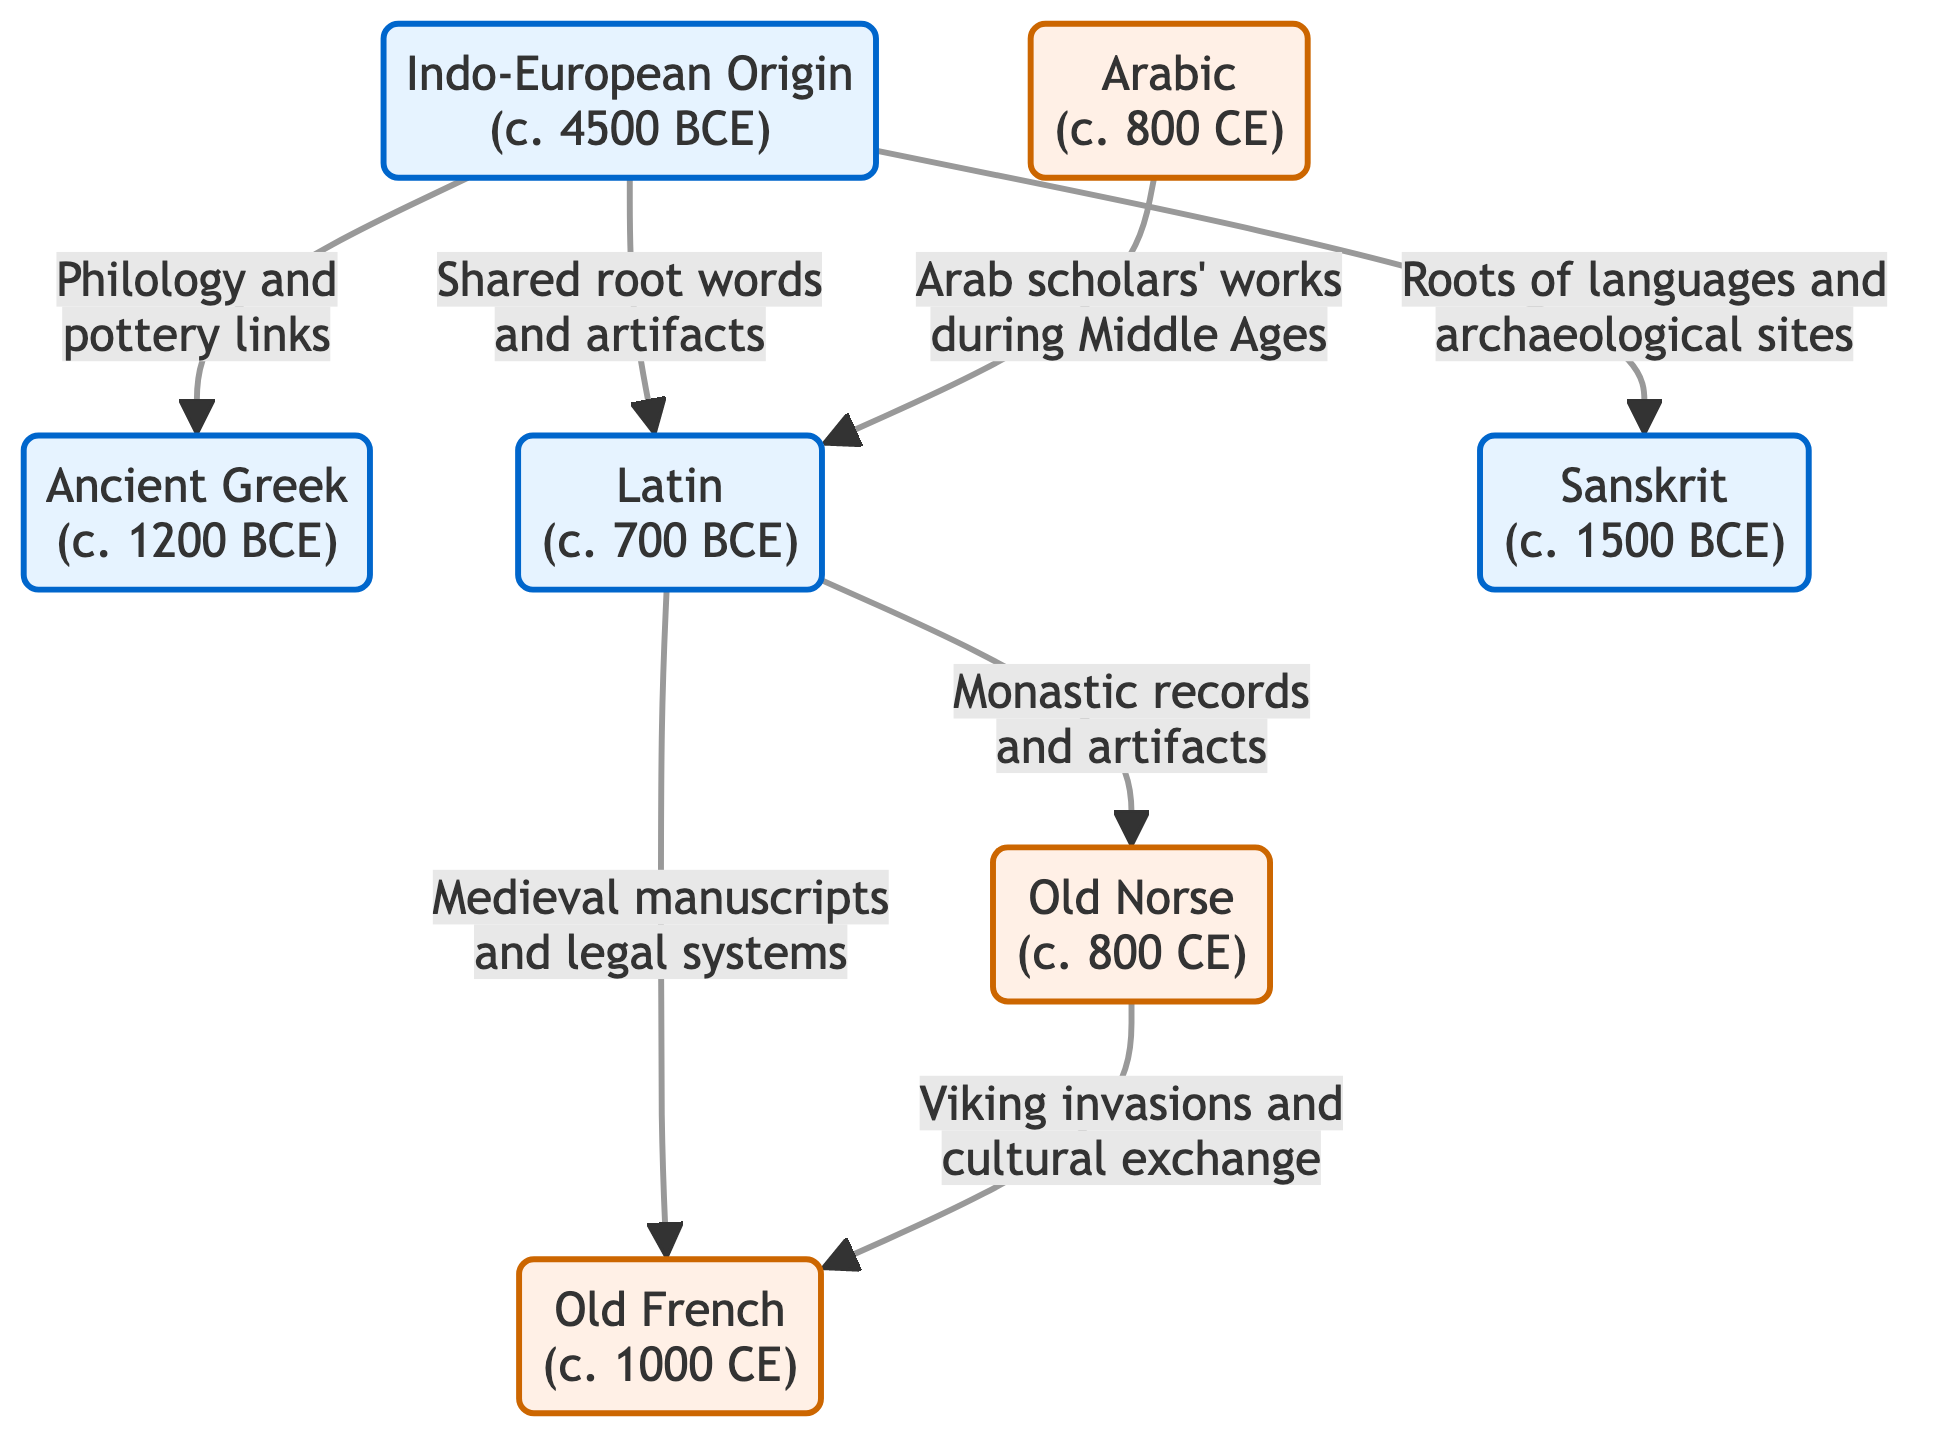What is the earliest date mentioned in the diagram? The diagram indicates the date of "Indo-European Origin" as c. 4500 BCE, which is the earliest point in the timeline presented, thus directly answering the question regarding the earliest date.
Answer: 4500 BCE How many ancient languages are represented in the diagram? The diagram lists three ancient languages: Ancient Greek, Latin, and Sanskrit, making it necessary to count only those specific nodes to provide the total number.
Answer: 3 What is the relation between Latin and Old French? The diagram indicates that the relationship is established through "Medieval manuscripts and legal systems," which means there is a direct connection regarding how Old French drew vocabulary or structure from Latin during the medieval period.
Answer: Medieval manuscripts and legal systems Which language is connected to Arabic in the diagram? By examining the arrows, it is clear that Arabic is connected to Latin through the link described as "Arab scholars' works during Middle Ages," indicating the linguistic exchange occurred in this context.
Answer: Latin What significant event related to Old Norse is mentioned in the diagram? The diagram points out "Viking invasions and cultural exchange" as the significant event, thereby identifying the historical context influencing Old Norse and its impact on language.
Answer: Viking invasions and cultural exchange Which ancient language is connected to both Latin and Old Norse? The diagram indicates that both Latin and Old Norse share a common link through their connections to Arthurian elements and manuscripts, but the one ancient language that connects directly to both is Latin as shown by their respective relationships to Old French.
Answer: Latin Which two languages were influenced by Latin according to the diagram? The diagram shows that both Old French and Old Norse are directly linked to Latin, implying that these languages drew influence from Latin through their respective historical contexts and interactions, thus yielding the two languages in the answer.
Answer: Old French and Old Norse How did Ancient Greek connect to Indo-European Origin in the diagram? The connection is depicted along the arrow marked with "Philology and pottery links," specifying the manner in which Ancient Greek evolved from the Indo-European roots identified in the diagram's available flow.
Answer: Philology and pottery links What type of findings correlate with the timeline of language borrowings represented in the diagram? The diagram indicates correlations with archaeological findings as noted in the connections made, especially with shared root words, artifacts, and contextual historical manuscripts which establish the connections between borrowed languages and their origins.
Answer: Archaeological findings 